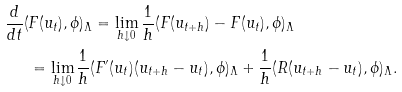<formula> <loc_0><loc_0><loc_500><loc_500>\frac { d } { d t } ( & F ( u _ { t } ) , \phi ) _ { \Lambda } = \lim _ { h \downarrow 0 } \frac { 1 } { h } ( F ( u _ { t + h } ) - F ( u _ { t } ) , \phi ) _ { \Lambda } \\ & = \lim _ { h \downarrow 0 } \frac { 1 } { h } ( F ^ { \prime } ( u _ { t } ) ( u _ { t + h } - u _ { t } ) , \phi ) _ { \Lambda } + \frac { 1 } { h } ( R ( u _ { t + h } - u _ { t } ) , \phi ) _ { \Lambda } .</formula> 